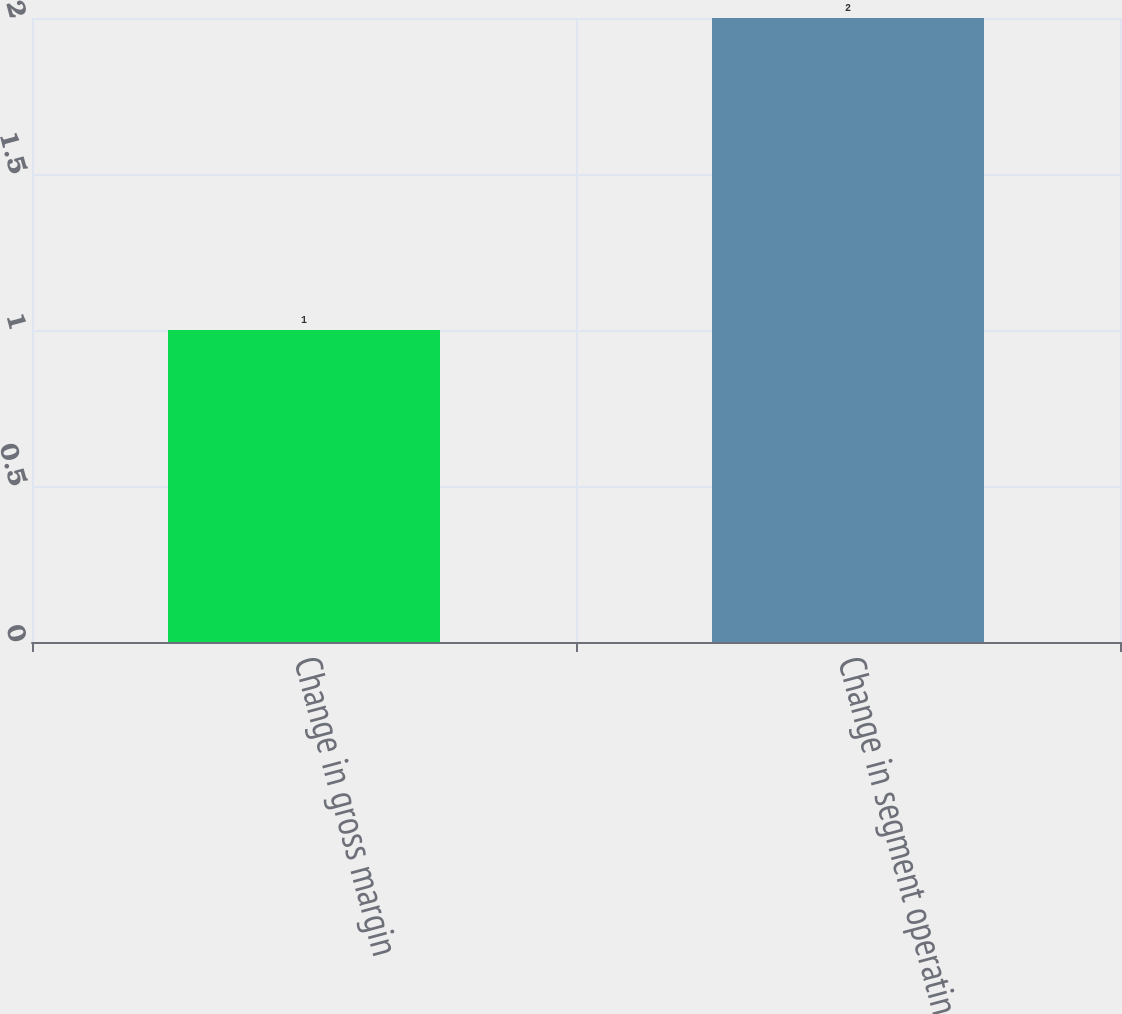Convert chart to OTSL. <chart><loc_0><loc_0><loc_500><loc_500><bar_chart><fcel>Change in gross margin<fcel>Change in segment operating<nl><fcel>1<fcel>2<nl></chart> 